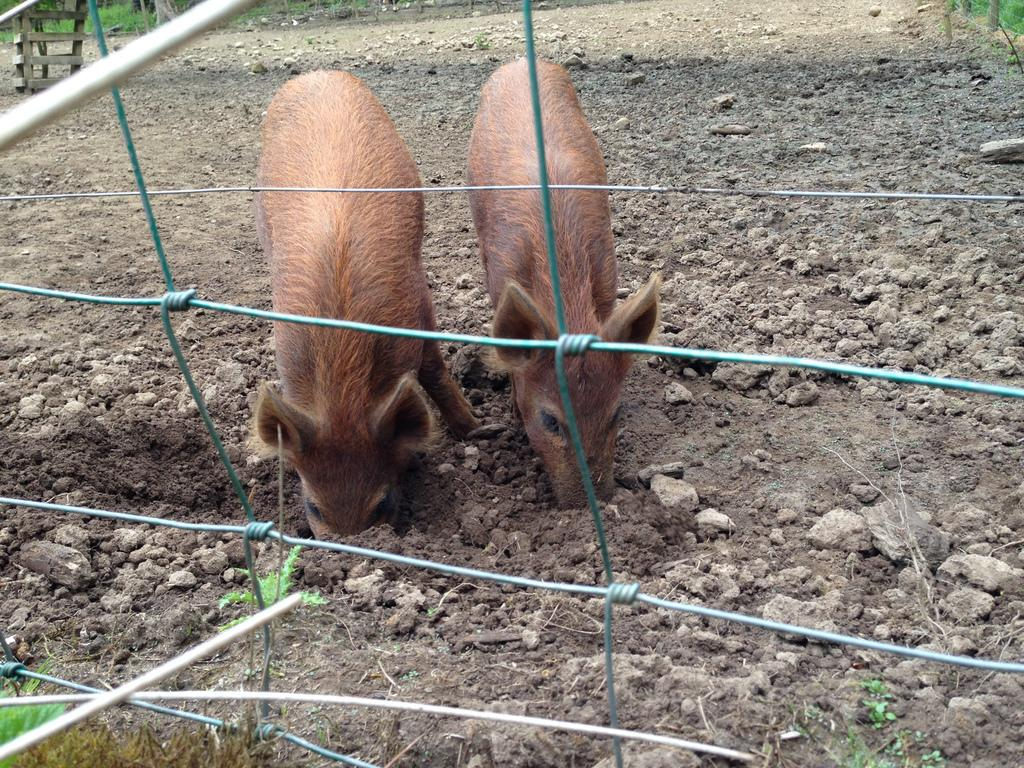How many animals are present in the image? There are two animals in the image. What color are the animals? The animals are brown in color. What is in front of the animals? There is fencing in front of the animals. What type of vegetation can be seen in the background of the image? There is green grass in the background of the image. How many bikes are leaning against the fence in the image? There are no bikes present in the image; it features two brown animals with fencing in front of them. Can you tell me the size of the cup that the animals are holding? There is no cup present in the image; the animals are not holding any objects. 